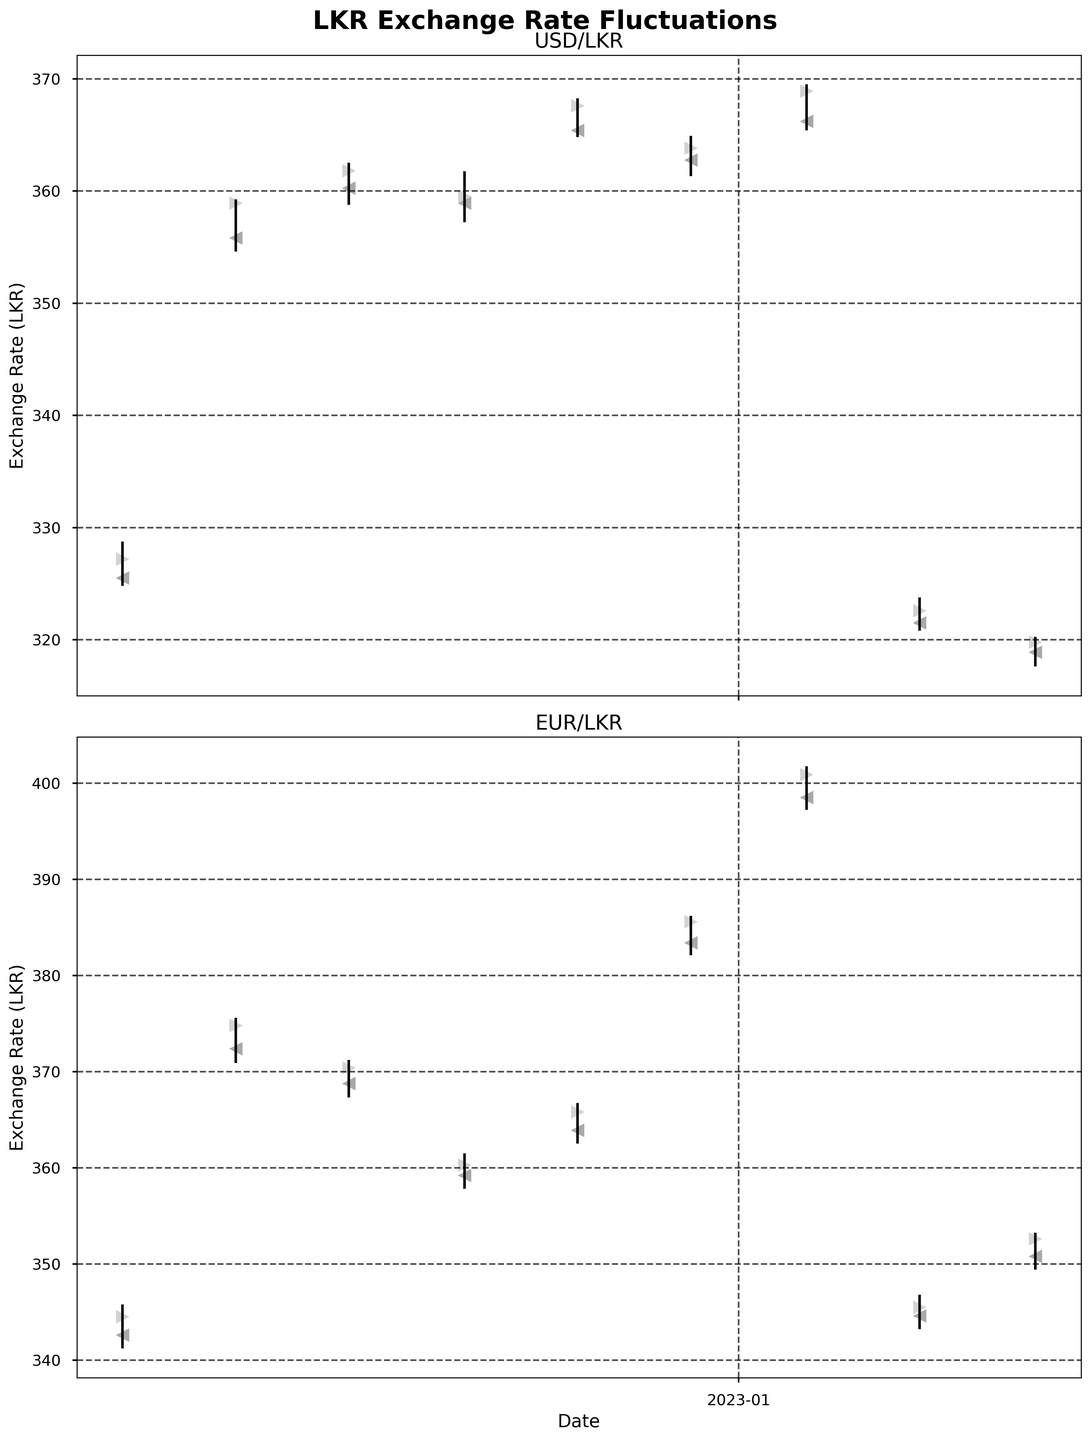What is the title of the figure? The title is generally written at the top of the chart. In this case, it says "LKR Exchange Rate Fluctuations."
Answer: LKR Exchange Rate Fluctuations What are the two major currencies shown in the figure? Look at the titles of the two subplots. The titles are 'USD/LKR' and 'EUR/LKR'.
Answer: USD and EUR What colors are used for the markers representing the opening and closing prices? The color of the opening price markers is dark gray, and the color of the closing price markers is light gray.
Answer: Dark gray and light gray Which USD/LKR date shows the highest exchange rate, and what is its value? Checking the vertical lines in the USD/LKR plot, the highest exchange rate occurs on October 29, 2022, with a high of 368.25.
Answer: October 29, 2022, with a value of 368.25 On which date did the EUR/LKR have the highest closing price in the past year? Look at the closing markers in the EUR/LKR plot and identify the highest point. The highest closing price for EUR/LKR happens on January 28, 2023, at 400.90.
Answer: January 28, 2023, with a value of 400.90 What is the difference between the highest and lowest USD/LKR exchange rates during the period shown? The highest rate is 369.50 (January 28, 2023), and the lowest rate is 317.60 (April 29, 2023), making the difference 369.50 - 317.60 = 51.90.
Answer: 51.90 Compare the opening prices of EUR/LKR on May 1, 2022, and May 1, 2023. Which is higher, and by how much? Compare the opening prices on the two dates. On May 1, 2022, the opening was 342.60, and on May 1, 2023, there is no data available. Hence, we can only use the available date.
Answer: 342.60 on May 1, 2022, with no data for May 1, 2023 What is the general trend of USD/LKR exchange rate from May 1, 2022, to April 29, 2023? Observing the values from May 1, 2022, where the exchange rate was around 327.20, to April 29, 2023, where it became 319.80, there is a slight downward trend.
Answer: Slight downward trend Which month in 2022 shows the highest volatility in USD/LKR exchange rates? Volatility can be inferred from the length of the vertical lines (high-low range). In this case, June 2022 with exchange rates ranging from 354.60 to 359.25 shows the highest volatility.
Answer: June 2022 What is the average closing price of USD/LKR for the whole period shown in the figure? Calculate the close prices: 327.20, 358.90, 361.80, 359.50, 367.60, 363.80, 368.90, 322.60, 319.80. Sum these values and divide by the number of data points: (327.20 + 358.90 + 361.80 + 359.50 + 367.60 + 363.80 + 368.90 + 322.60 + 319.80) / 9 = 358.01.
Answer: 358.01 